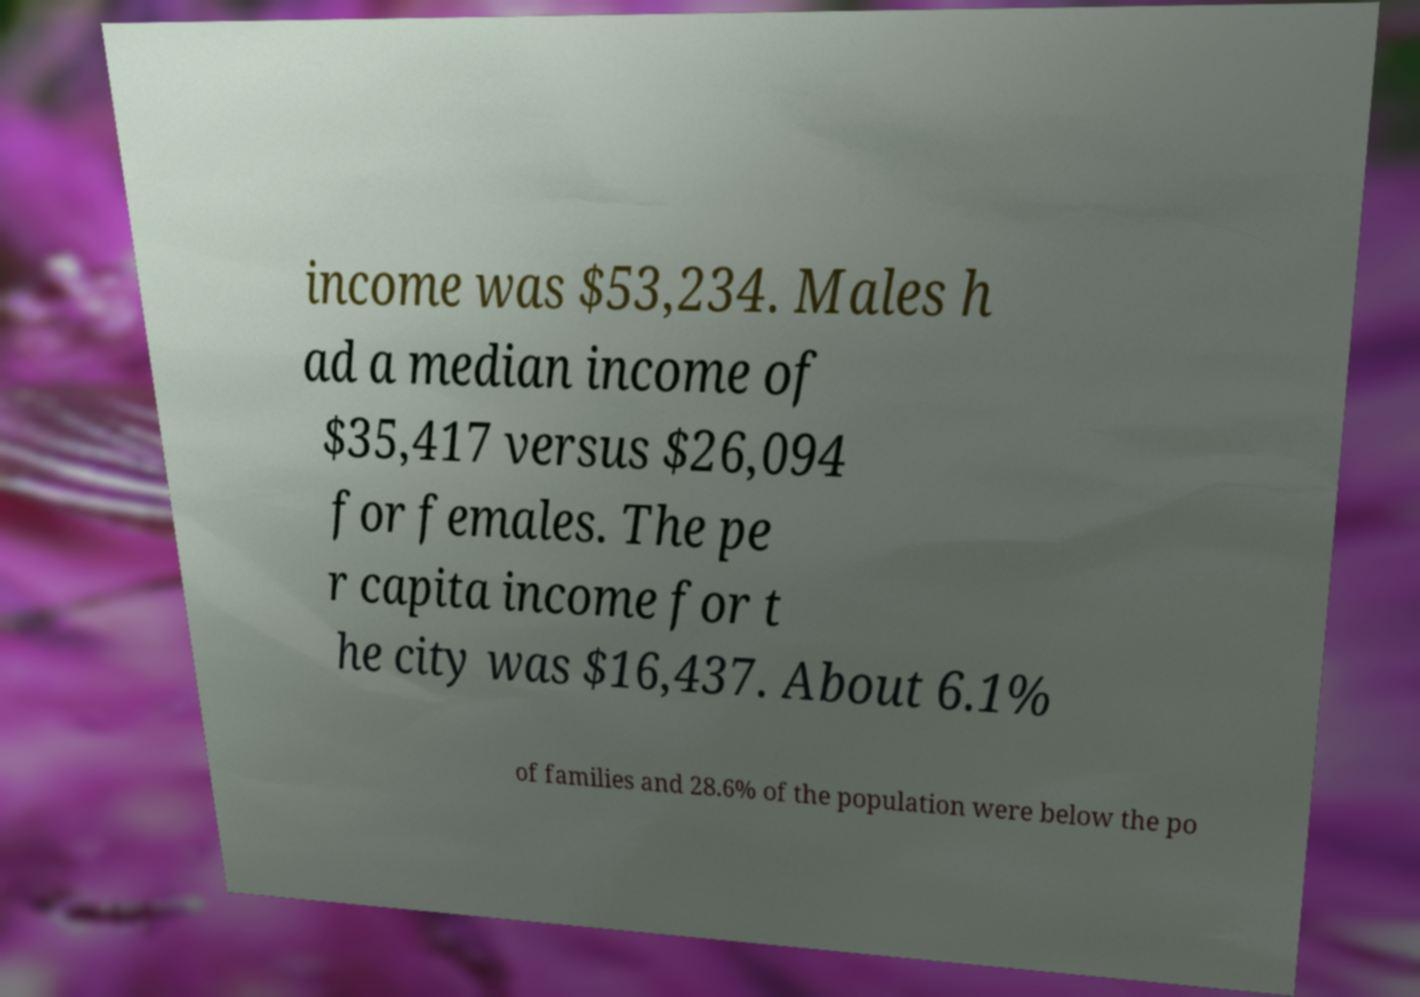I need the written content from this picture converted into text. Can you do that? income was $53,234. Males h ad a median income of $35,417 versus $26,094 for females. The pe r capita income for t he city was $16,437. About 6.1% of families and 28.6% of the population were below the po 